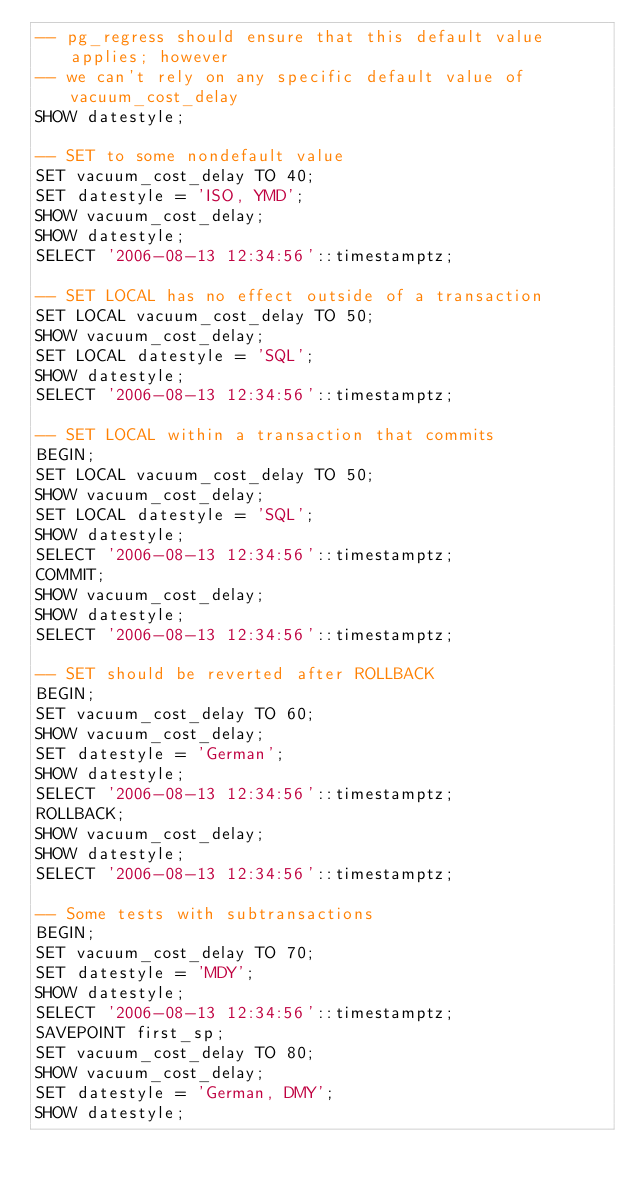<code> <loc_0><loc_0><loc_500><loc_500><_SQL_>-- pg_regress should ensure that this default value applies; however
-- we can't rely on any specific default value of vacuum_cost_delay
SHOW datestyle;

-- SET to some nondefault value
SET vacuum_cost_delay TO 40;
SET datestyle = 'ISO, YMD';
SHOW vacuum_cost_delay;
SHOW datestyle;
SELECT '2006-08-13 12:34:56'::timestamptz;

-- SET LOCAL has no effect outside of a transaction
SET LOCAL vacuum_cost_delay TO 50;
SHOW vacuum_cost_delay;
SET LOCAL datestyle = 'SQL';
SHOW datestyle;
SELECT '2006-08-13 12:34:56'::timestamptz;

-- SET LOCAL within a transaction that commits
BEGIN;
SET LOCAL vacuum_cost_delay TO 50;
SHOW vacuum_cost_delay;
SET LOCAL datestyle = 'SQL';
SHOW datestyle;
SELECT '2006-08-13 12:34:56'::timestamptz;
COMMIT;
SHOW vacuum_cost_delay;
SHOW datestyle;
SELECT '2006-08-13 12:34:56'::timestamptz;

-- SET should be reverted after ROLLBACK
BEGIN;
SET vacuum_cost_delay TO 60;
SHOW vacuum_cost_delay;
SET datestyle = 'German';
SHOW datestyle;
SELECT '2006-08-13 12:34:56'::timestamptz;
ROLLBACK;
SHOW vacuum_cost_delay;
SHOW datestyle;
SELECT '2006-08-13 12:34:56'::timestamptz;

-- Some tests with subtransactions
BEGIN;
SET vacuum_cost_delay TO 70;
SET datestyle = 'MDY';
SHOW datestyle;
SELECT '2006-08-13 12:34:56'::timestamptz;
SAVEPOINT first_sp;
SET vacuum_cost_delay TO 80;
SHOW vacuum_cost_delay;
SET datestyle = 'German, DMY';
SHOW datestyle;</code> 